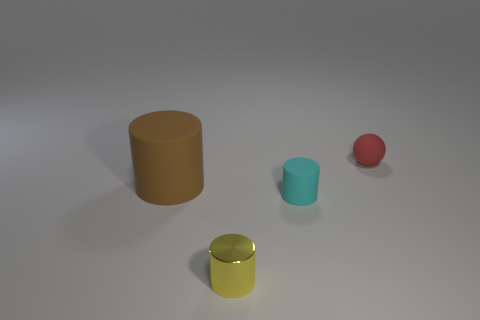Are there any other things that have the same material as the tiny yellow thing?
Make the answer very short. No. How many other things are there of the same material as the small yellow object?
Your answer should be compact. 0. How many shiny objects are cyan cylinders or tiny red cylinders?
Make the answer very short. 0. Does the small thing behind the big cylinder have the same shape as the yellow metallic thing?
Provide a short and direct response. No. Is the number of brown cylinders that are behind the tiny matte sphere greater than the number of objects?
Your response must be concise. No. How many matte things are right of the tiny metallic thing and on the left side of the red sphere?
Your answer should be compact. 1. The tiny rubber object that is behind the small matte object left of the red object is what color?
Offer a terse response. Red. How many other tiny cylinders are the same color as the metal cylinder?
Ensure brevity in your answer.  0. There is a small ball; is it the same color as the rubber object that is in front of the big brown thing?
Your answer should be compact. No. Is the number of tiny green shiny cylinders less than the number of red matte spheres?
Offer a terse response. Yes. 